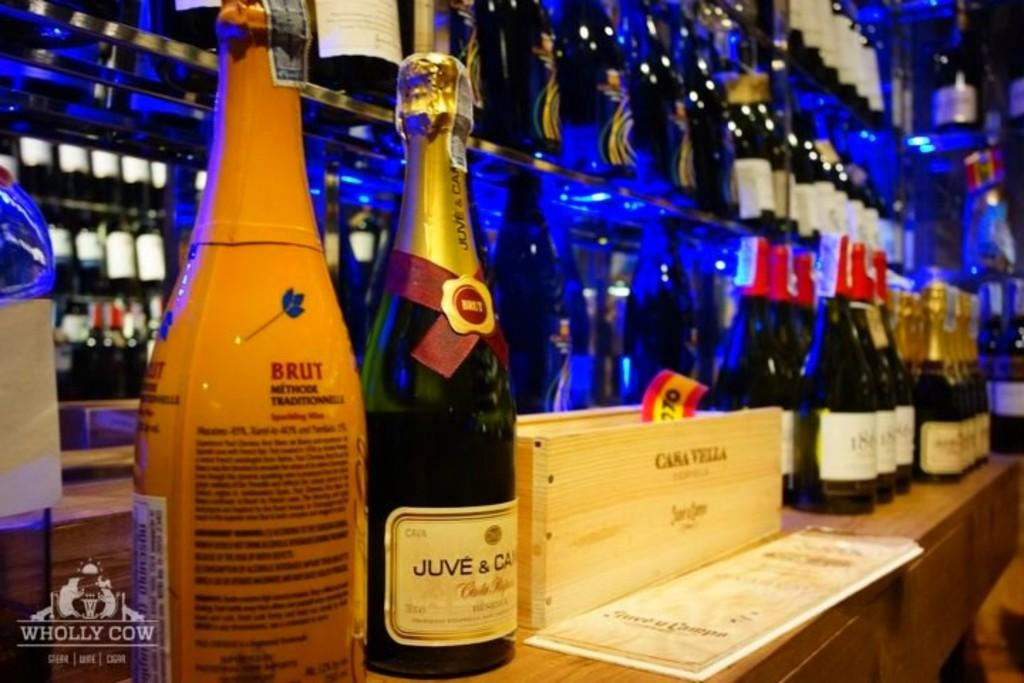Provide a one-sentence caption for the provided image. Bottles of champagne displayed at a bar named "Wholly Cow". 